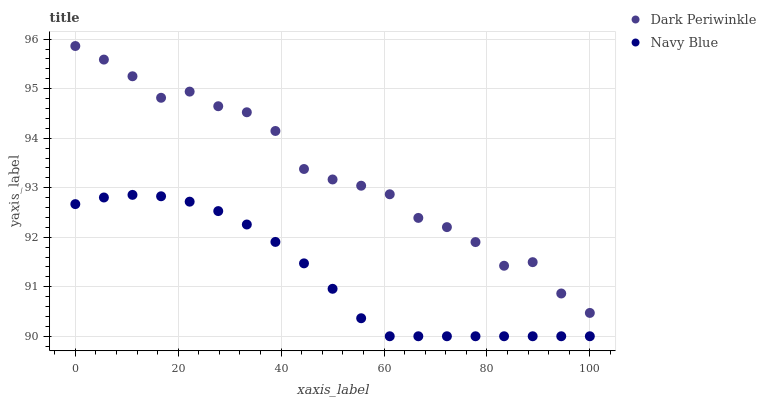Does Navy Blue have the minimum area under the curve?
Answer yes or no. Yes. Does Dark Periwinkle have the maximum area under the curve?
Answer yes or no. Yes. Does Dark Periwinkle have the minimum area under the curve?
Answer yes or no. No. Is Navy Blue the smoothest?
Answer yes or no. Yes. Is Dark Periwinkle the roughest?
Answer yes or no. Yes. Is Dark Periwinkle the smoothest?
Answer yes or no. No. Does Navy Blue have the lowest value?
Answer yes or no. Yes. Does Dark Periwinkle have the lowest value?
Answer yes or no. No. Does Dark Periwinkle have the highest value?
Answer yes or no. Yes. Is Navy Blue less than Dark Periwinkle?
Answer yes or no. Yes. Is Dark Periwinkle greater than Navy Blue?
Answer yes or no. Yes. Does Navy Blue intersect Dark Periwinkle?
Answer yes or no. No. 